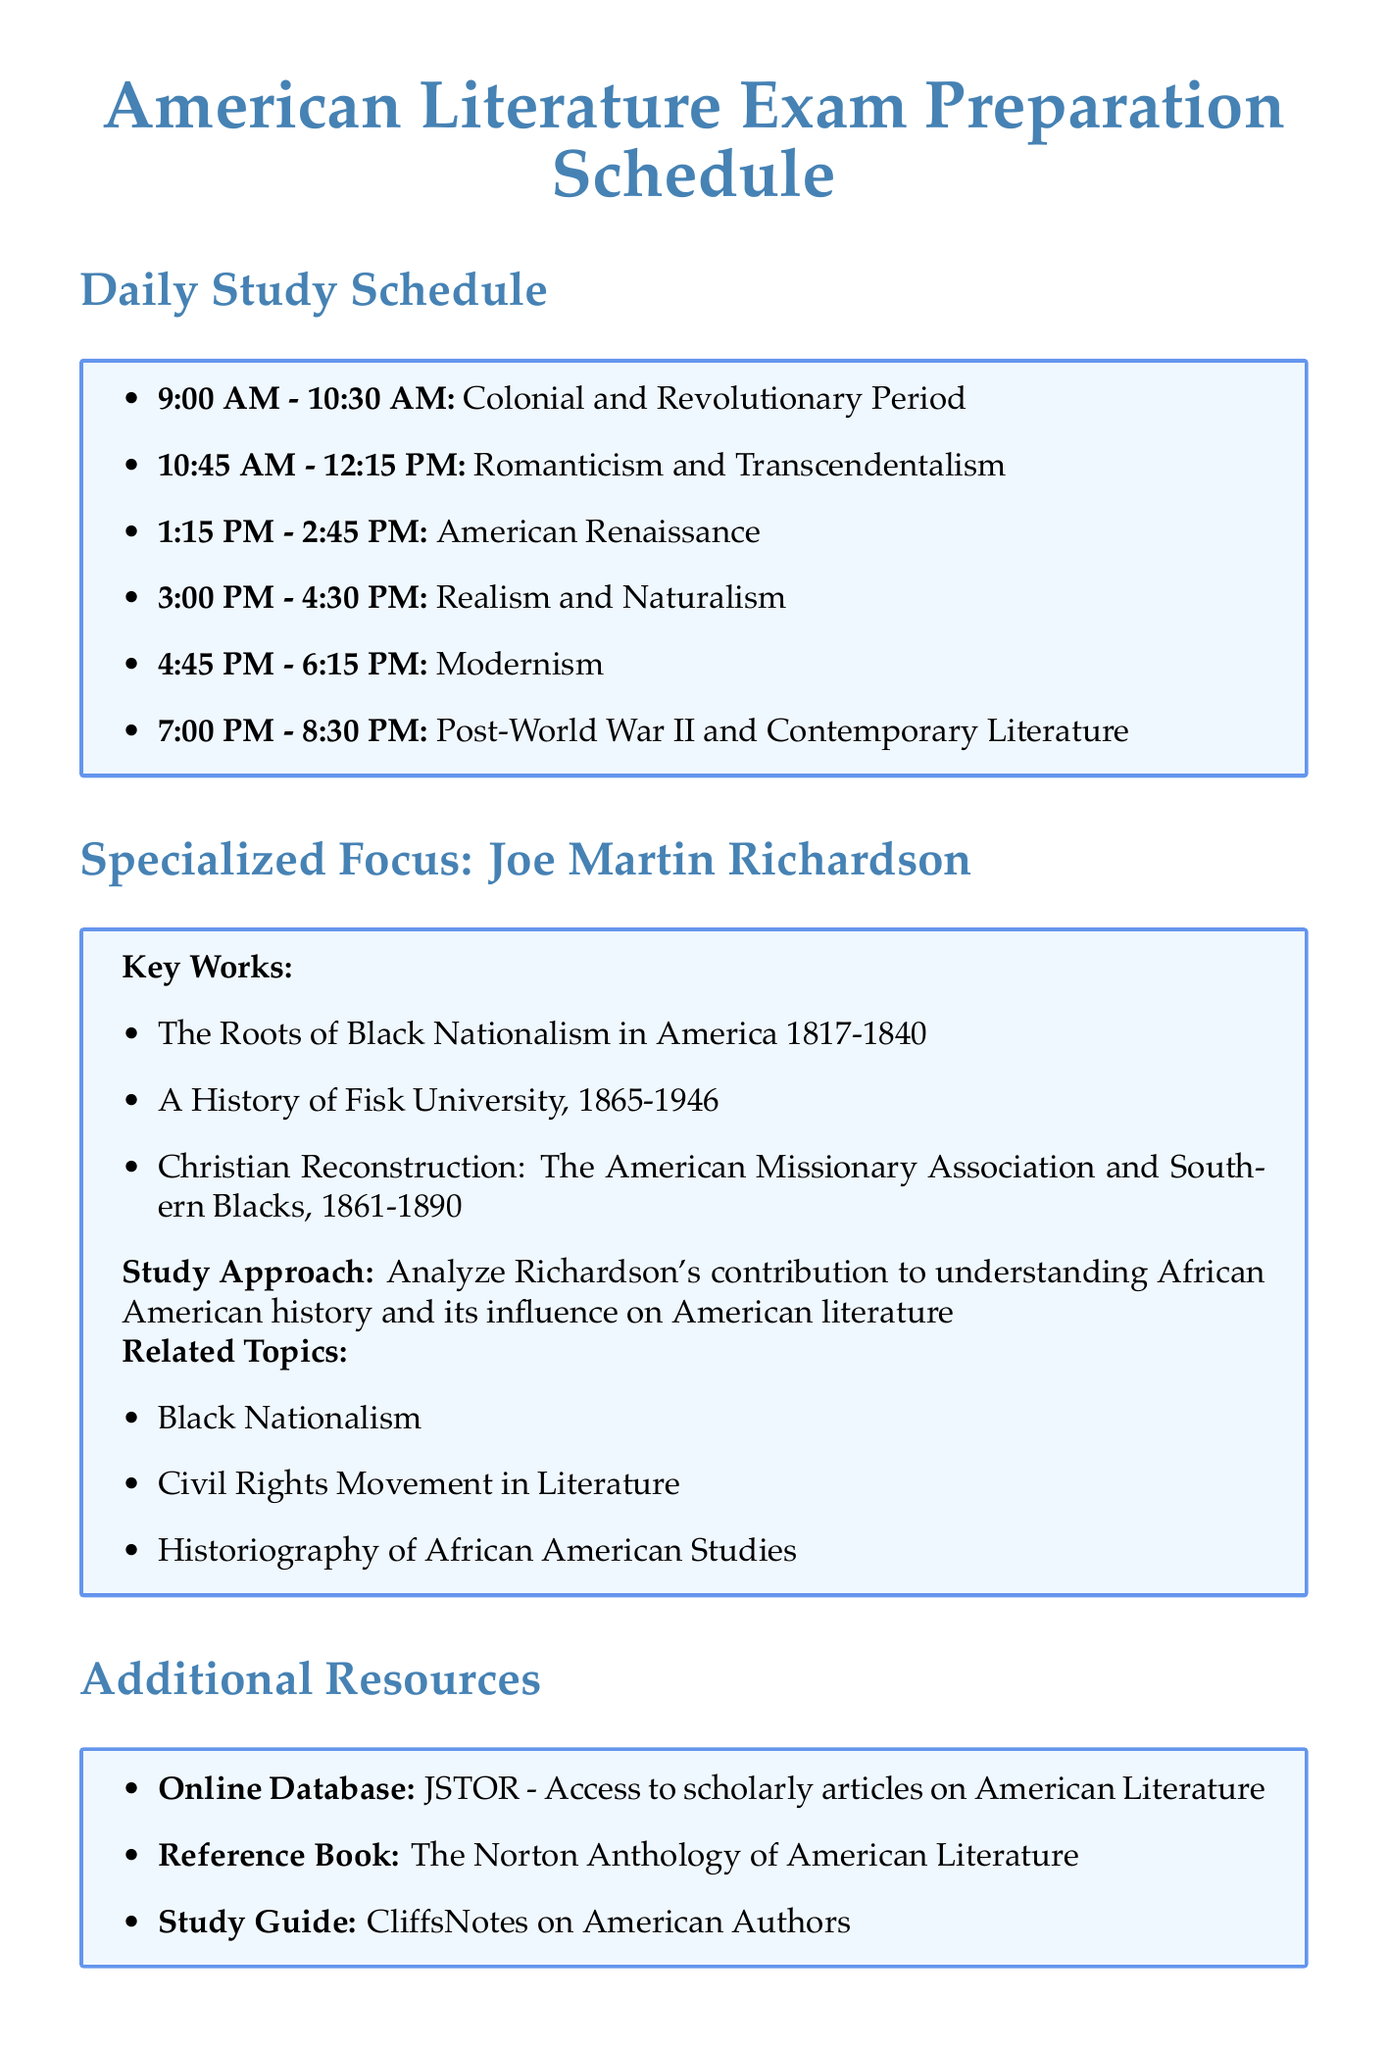what time is the first study block scheduled? The first study block is listed as starting at 9:00 AM.
Answer: 9:00 AM who are the authors studied during the Modernism block? The document specifies which authors to focus on during the Modernism study block.
Answer: F. Scott Fitzgerald, Ernest Hemingway, William Faulkner how long is each study block? The duration of each study block is mentioned in the schedule as a specified time range.
Answer: 1.5 hours what is the last focus area of the day? The schedule outlines various focus areas throughout the day, with the last one being at the end.
Answer: Post-World War II and Contemporary Literature which author has a specialized focus in the schedule? The document highlights a specific author for specialized study, referring to their contributions.
Answer: Joe Martin Richardson what is one of the key works by Joe Martin Richardson? The schedule lists key works associated with Joe Martin Richardson to aid in focused study.
Answer: The Roots of Black Nationalism in America 1817-1840 what is one exam preparation tip provided? The document includes advice for effective exam preparation and strategy.
Answer: Create concise summaries for each literary movement how many total study hours are allocated per day? The document states the total hours dedicated to study each day for exam preparation.
Answer: 8 hours what is the name of the reference book listed? The additional resources section includes books and databases for further study, naming specific works.
Answer: The Norton Anthology of American Literature 